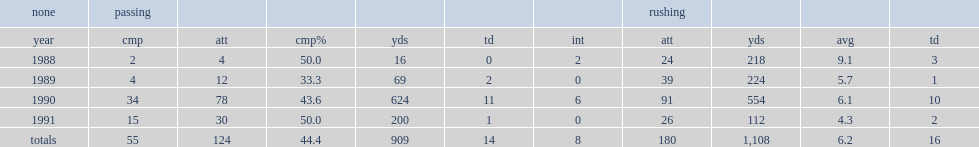How many rushing yards did mickey joseph get in 1991? 112.0. Could you parse the entire table as a dict? {'header': ['none', 'passing', '', '', '', '', '', 'rushing', '', '', ''], 'rows': [['year', 'cmp', 'att', 'cmp%', 'yds', 'td', 'int', 'att', 'yds', 'avg', 'td'], ['1988', '2', '4', '50.0', '16', '0', '2', '24', '218', '9.1', '3'], ['1989', '4', '12', '33.3', '69', '2', '0', '39', '224', '5.7', '1'], ['1990', '34', '78', '43.6', '624', '11', '6', '91', '554', '6.1', '10'], ['1991', '15', '30', '50.0', '200', '1', '0', '26', '112', '4.3', '2'], ['totals', '55', '124', '44.4', '909', '14', '8', '180', '1,108', '6.2', '16']]} 